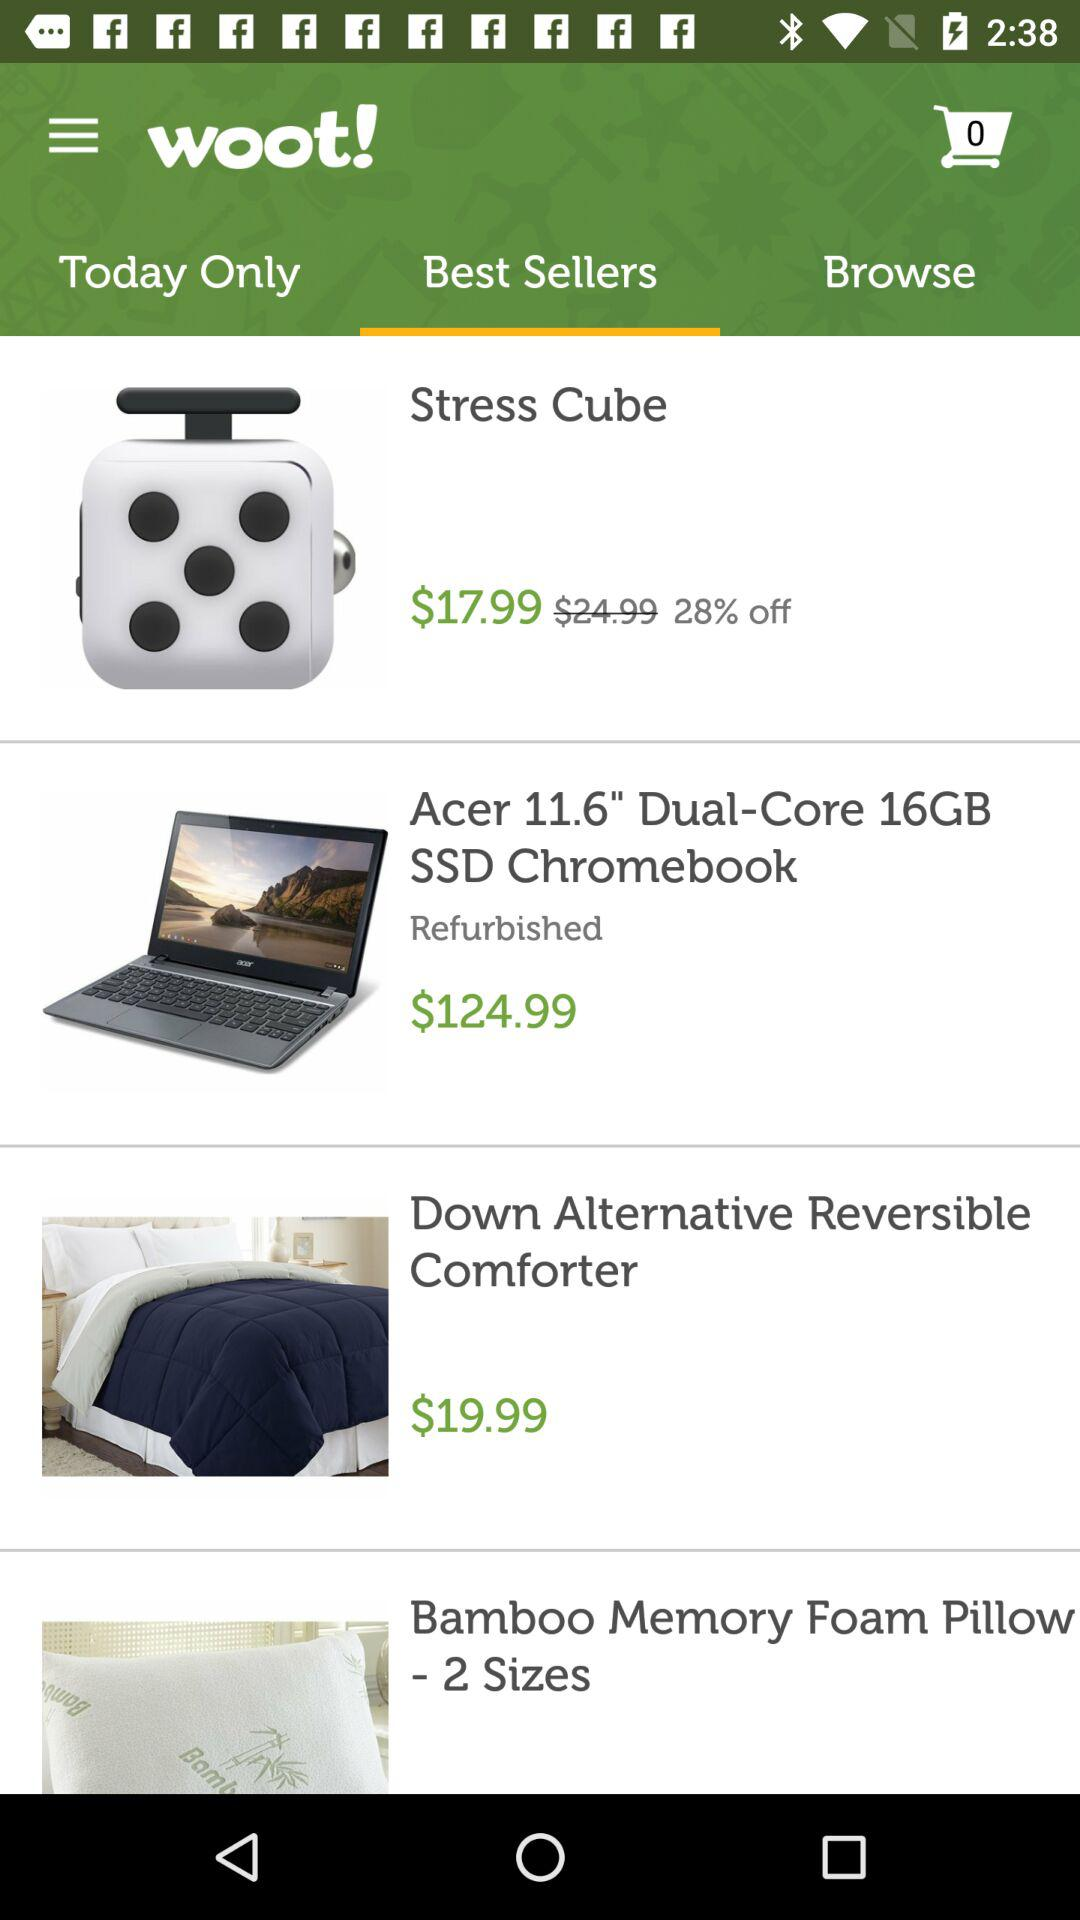How much does the "Down Alternative Reversible" cost? The "Down Alternative Reversible" costs $19.99. 